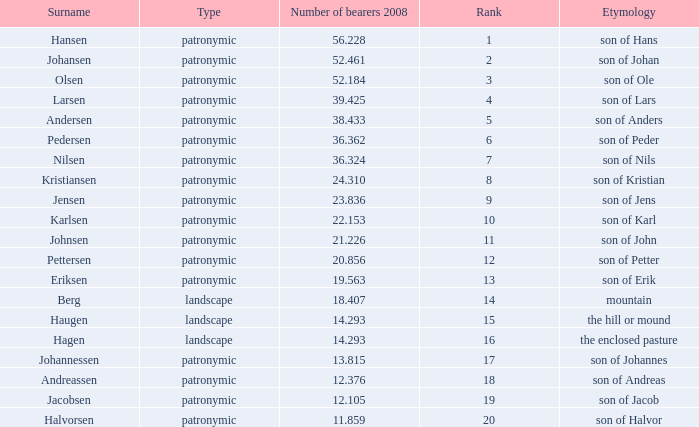Would you mind parsing the complete table? {'header': ['Surname', 'Type', 'Number of bearers 2008', 'Rank', 'Etymology'], 'rows': [['Hansen', 'patronymic', '56.228', '1', 'son of Hans'], ['Johansen', 'patronymic', '52.461', '2', 'son of Johan'], ['Olsen', 'patronymic', '52.184', '3', 'son of Ole'], ['Larsen', 'patronymic', '39.425', '4', 'son of Lars'], ['Andersen', 'patronymic', '38.433', '5', 'son of Anders'], ['Pedersen', 'patronymic', '36.362', '6', 'son of Peder'], ['Nilsen', 'patronymic', '36.324', '7', 'son of Nils'], ['Kristiansen', 'patronymic', '24.310', '8', 'son of Kristian'], ['Jensen', 'patronymic', '23.836', '9', 'son of Jens'], ['Karlsen', 'patronymic', '22.153', '10', 'son of Karl'], ['Johnsen', 'patronymic', '21.226', '11', 'son of John'], ['Pettersen', 'patronymic', '20.856', '12', 'son of Petter'], ['Eriksen', 'patronymic', '19.563', '13', 'son of Erik'], ['Berg', 'landscape', '18.407', '14', 'mountain'], ['Haugen', 'landscape', '14.293', '15', 'the hill or mound'], ['Hagen', 'landscape', '14.293', '16', 'the enclosed pasture'], ['Johannessen', 'patronymic', '13.815', '17', 'son of Johannes'], ['Andreassen', 'patronymic', '12.376', '18', 'son of Andreas'], ['Jacobsen', 'patronymic', '12.105', '19', 'son of Jacob'], ['Halvorsen', 'patronymic', '11.859', '20', 'son of Halvor']]} What is Type, when Number of Bearers 2008 is greater than 12.376, when Rank is greater than 3, and when Etymology is Son of Jens? Patronymic. 